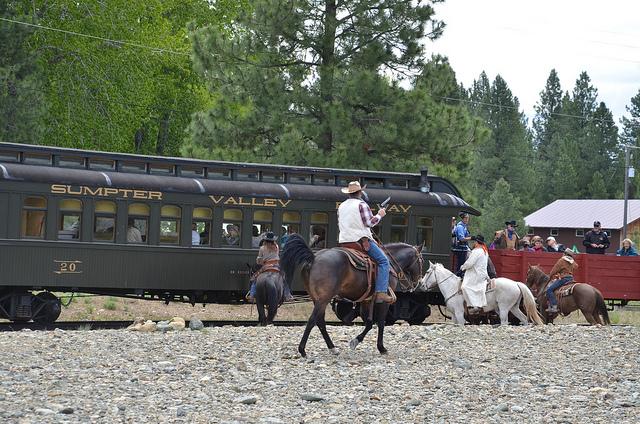What animals are seen?
Be succinct. Horses. What has been written on the train?
Write a very short answer. Sumpter valley. Is someone robbing the train?
Keep it brief. Yes. 